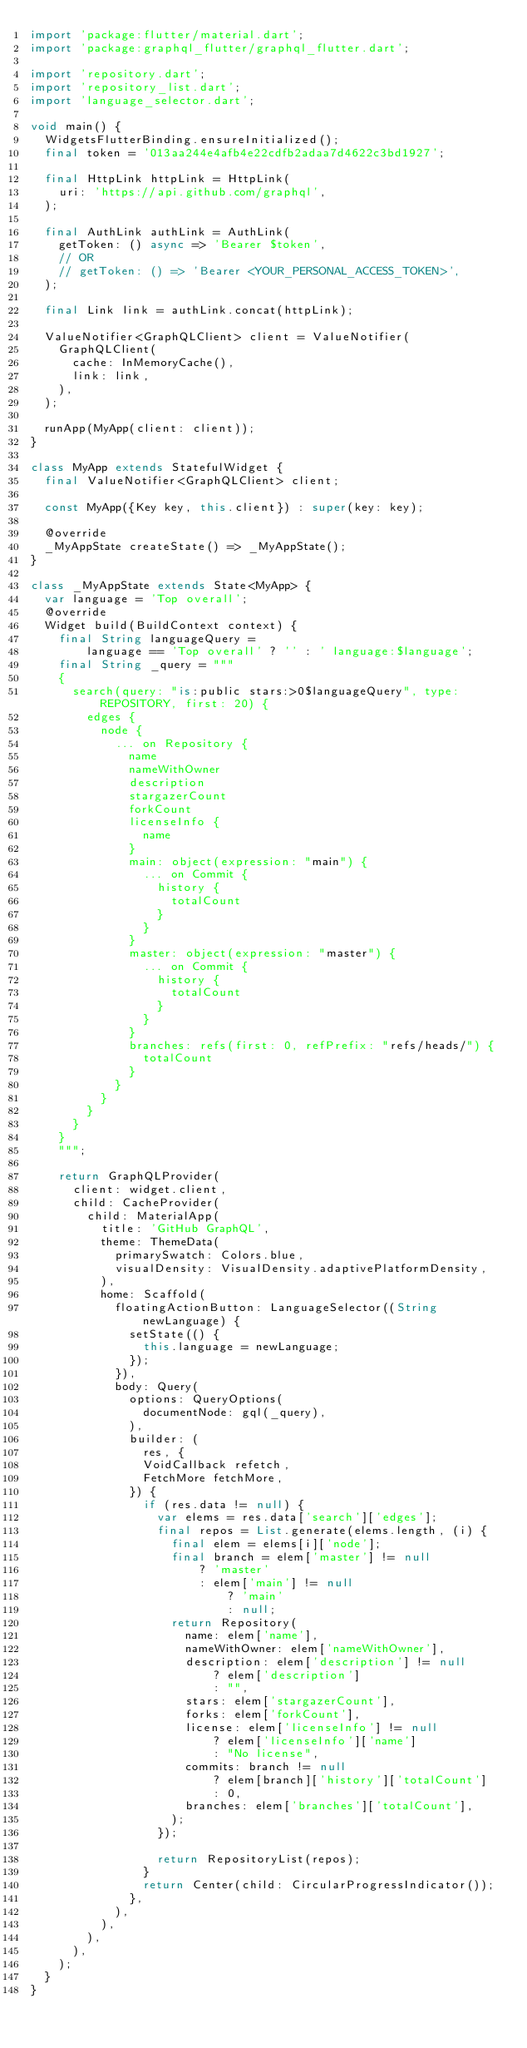<code> <loc_0><loc_0><loc_500><loc_500><_Dart_>import 'package:flutter/material.dart';
import 'package:graphql_flutter/graphql_flutter.dart';

import 'repository.dart';
import 'repository_list.dart';
import 'language_selector.dart';

void main() {
  WidgetsFlutterBinding.ensureInitialized();
  final token = '013aa244e4afb4e22cdfb2adaa7d4622c3bd1927';

  final HttpLink httpLink = HttpLink(
    uri: 'https://api.github.com/graphql',
  );

  final AuthLink authLink = AuthLink(
    getToken: () async => 'Bearer $token',
    // OR
    // getToken: () => 'Bearer <YOUR_PERSONAL_ACCESS_TOKEN>',
  );

  final Link link = authLink.concat(httpLink);

  ValueNotifier<GraphQLClient> client = ValueNotifier(
    GraphQLClient(
      cache: InMemoryCache(),
      link: link,
    ),
  );

  runApp(MyApp(client: client));
}

class MyApp extends StatefulWidget {
  final ValueNotifier<GraphQLClient> client;

  const MyApp({Key key, this.client}) : super(key: key);

  @override
  _MyAppState createState() => _MyAppState();
}

class _MyAppState extends State<MyApp> {
  var language = 'Top overall';
  @override
  Widget build(BuildContext context) {
    final String languageQuery =
        language == 'Top overall' ? '' : ' language:$language';
    final String _query = """
    {
      search(query: "is:public stars:>0$languageQuery", type: REPOSITORY, first: 20) {
        edges {
          node {
            ... on Repository {
              name
              nameWithOwner
              description
              stargazerCount
              forkCount
              licenseInfo {
                name
              }
              main: object(expression: "main") {
                ... on Commit {
                  history {
                    totalCount
                  }
                }
              }
              master: object(expression: "master") {
                ... on Commit {
                  history {
                    totalCount
                  }
                }
              }
              branches: refs(first: 0, refPrefix: "refs/heads/") {
                totalCount
              }
            }
          }
        }
      }
    }
    """;

    return GraphQLProvider(
      client: widget.client,
      child: CacheProvider(
        child: MaterialApp(
          title: 'GitHub GraphQL',
          theme: ThemeData(
            primarySwatch: Colors.blue,
            visualDensity: VisualDensity.adaptivePlatformDensity,
          ),
          home: Scaffold(
            floatingActionButton: LanguageSelector((String newLanguage) {
              setState(() {
                this.language = newLanguage;
              });
            }),
            body: Query(
              options: QueryOptions(
                documentNode: gql(_query),
              ),
              builder: (
                res, {
                VoidCallback refetch,
                FetchMore fetchMore,
              }) {
                if (res.data != null) {
                  var elems = res.data['search']['edges'];
                  final repos = List.generate(elems.length, (i) {
                    final elem = elems[i]['node'];
                    final branch = elem['master'] != null
                        ? 'master'
                        : elem['main'] != null
                            ? 'main'
                            : null;
                    return Repository(
                      name: elem['name'],
                      nameWithOwner: elem['nameWithOwner'],
                      description: elem['description'] != null
                          ? elem['description']
                          : "",
                      stars: elem['stargazerCount'],
                      forks: elem['forkCount'],
                      license: elem['licenseInfo'] != null
                          ? elem['licenseInfo']['name']
                          : "No license",
                      commits: branch != null
                          ? elem[branch]['history']['totalCount']
                          : 0,
                      branches: elem['branches']['totalCount'],
                    );
                  });

                  return RepositoryList(repos);
                }
                return Center(child: CircularProgressIndicator());
              },
            ),
          ),
        ),
      ),
    );
  }
}
</code> 